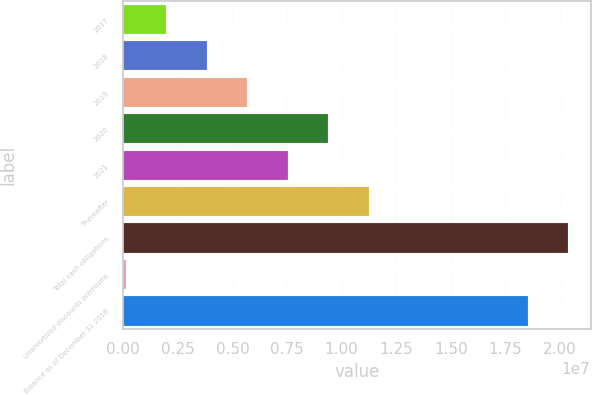Convert chart. <chart><loc_0><loc_0><loc_500><loc_500><bar_chart><fcel>2017<fcel>2018<fcel>2019<fcel>2020<fcel>2021<fcel>Thereafter<fcel>Total cash obligations<fcel>Unamortized discounts premiums<fcel>Balance as of December 31 2016<nl><fcel>1.97279e+06<fcel>3.82613e+06<fcel>5.67948e+06<fcel>9.38617e+06<fcel>7.53282e+06<fcel>1.12395e+07<fcel>2.03868e+07<fcel>119439<fcel>1.85335e+07<nl></chart> 